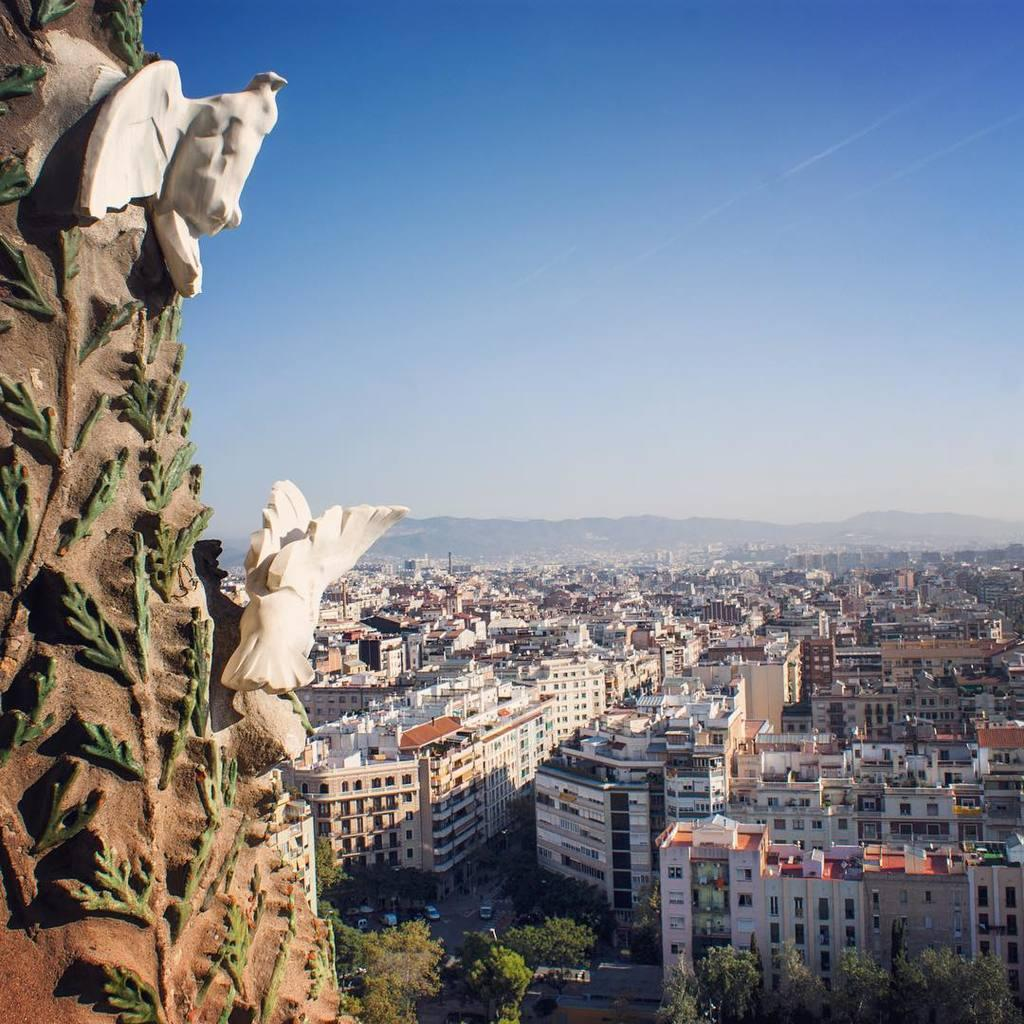What type of animals are depicted as statues in the image? There are statues of two birds in the image. What type of natural vegetation is present in the image? There are trees in the image. What type of man-made structures are present in the image? There are buildings in the image. What type of artificial lighting is present in the image? There are light poles in the image. What type of geographical feature is present in the image? There are mountains in the image. What type of transportation is present in the image? There are vehicles on the road in the image. What part of the natural environment is visible in the image? The sky is visible in the image. What time of day is the image likely to have been taken? The image was likely taken during the day, as there is no indication of darkness or artificial lighting. Where is the dad in the image? There is no dad present in the image. What type of wind is blowing the zephyr in the image? There is no zephyr present in the image, as it is a mythological term for a gentle breeze and not a physical object. 